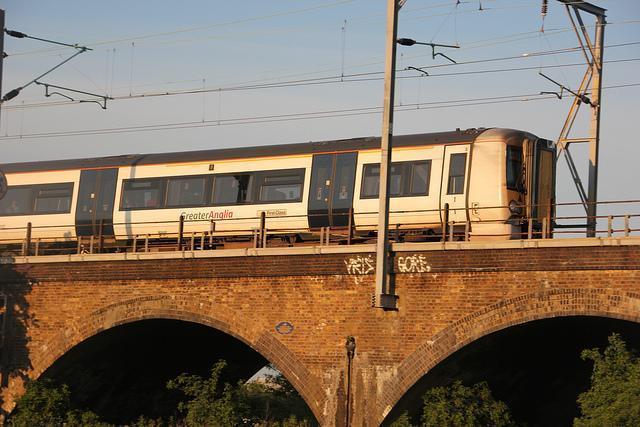How many elephants are facing the camera?
Give a very brief answer. 0. 